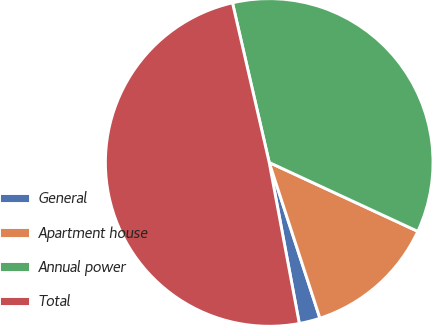Convert chart to OTSL. <chart><loc_0><loc_0><loc_500><loc_500><pie_chart><fcel>General<fcel>Apartment house<fcel>Annual power<fcel>Total<nl><fcel>2.07%<fcel>13.08%<fcel>35.51%<fcel>49.34%<nl></chart> 